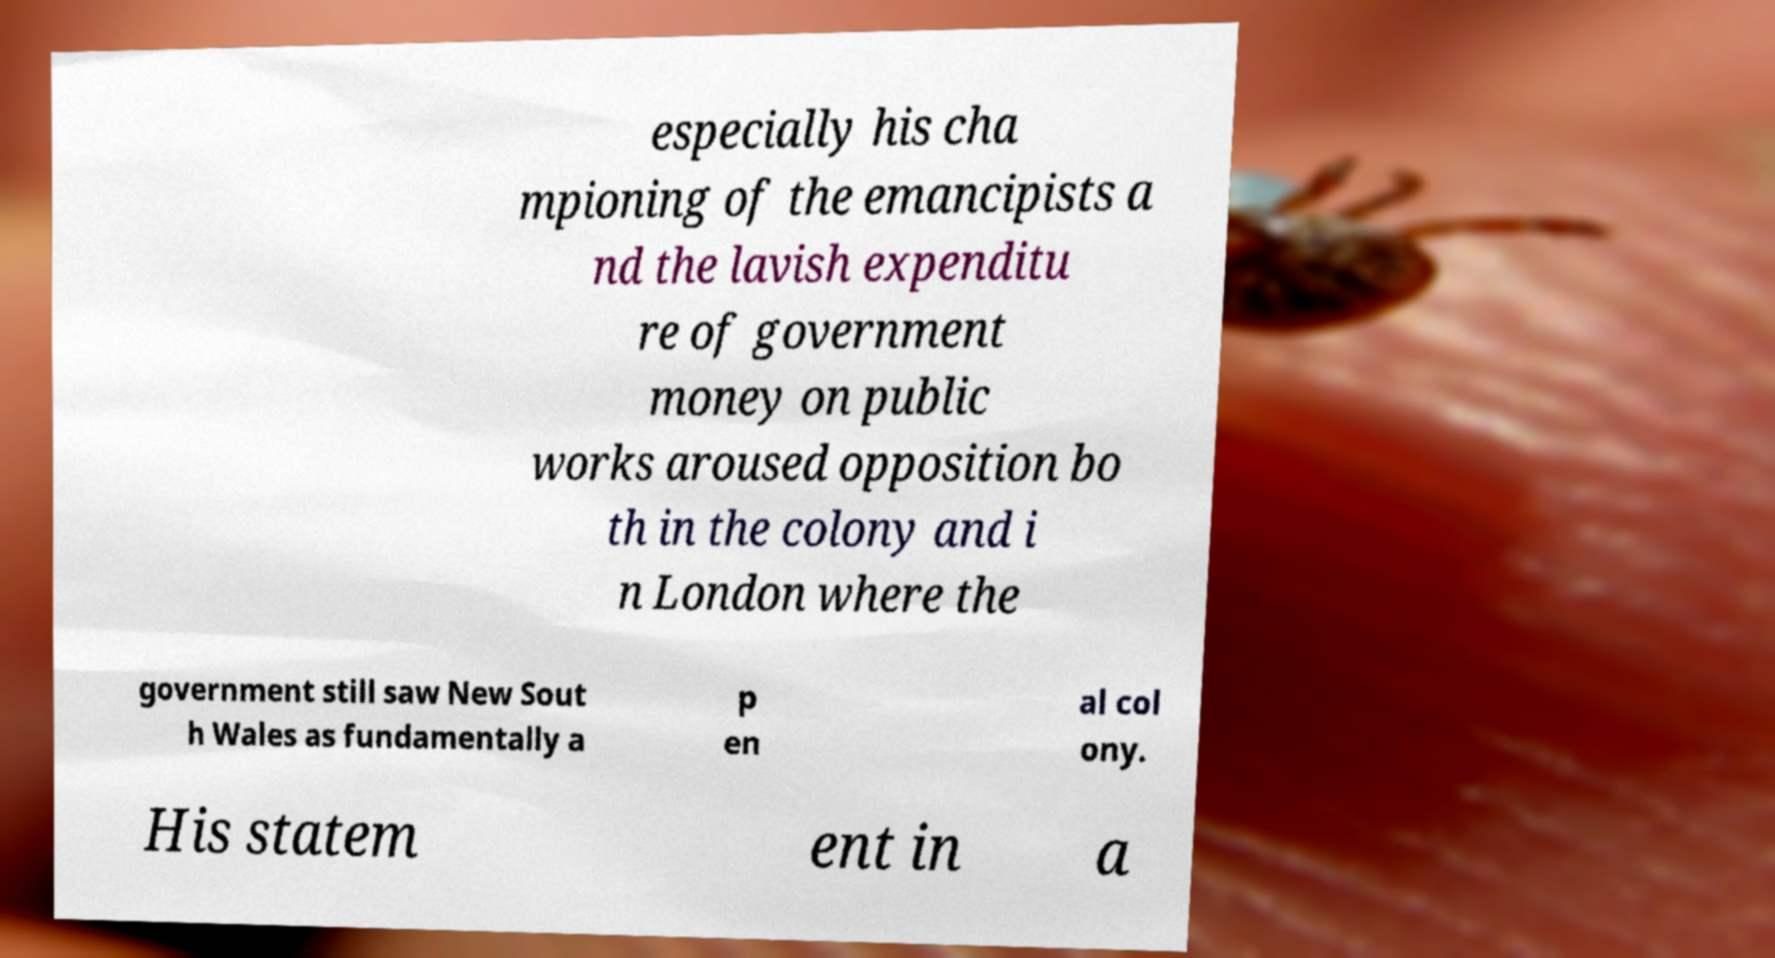For documentation purposes, I need the text within this image transcribed. Could you provide that? especially his cha mpioning of the emancipists a nd the lavish expenditu re of government money on public works aroused opposition bo th in the colony and i n London where the government still saw New Sout h Wales as fundamentally a p en al col ony. His statem ent in a 